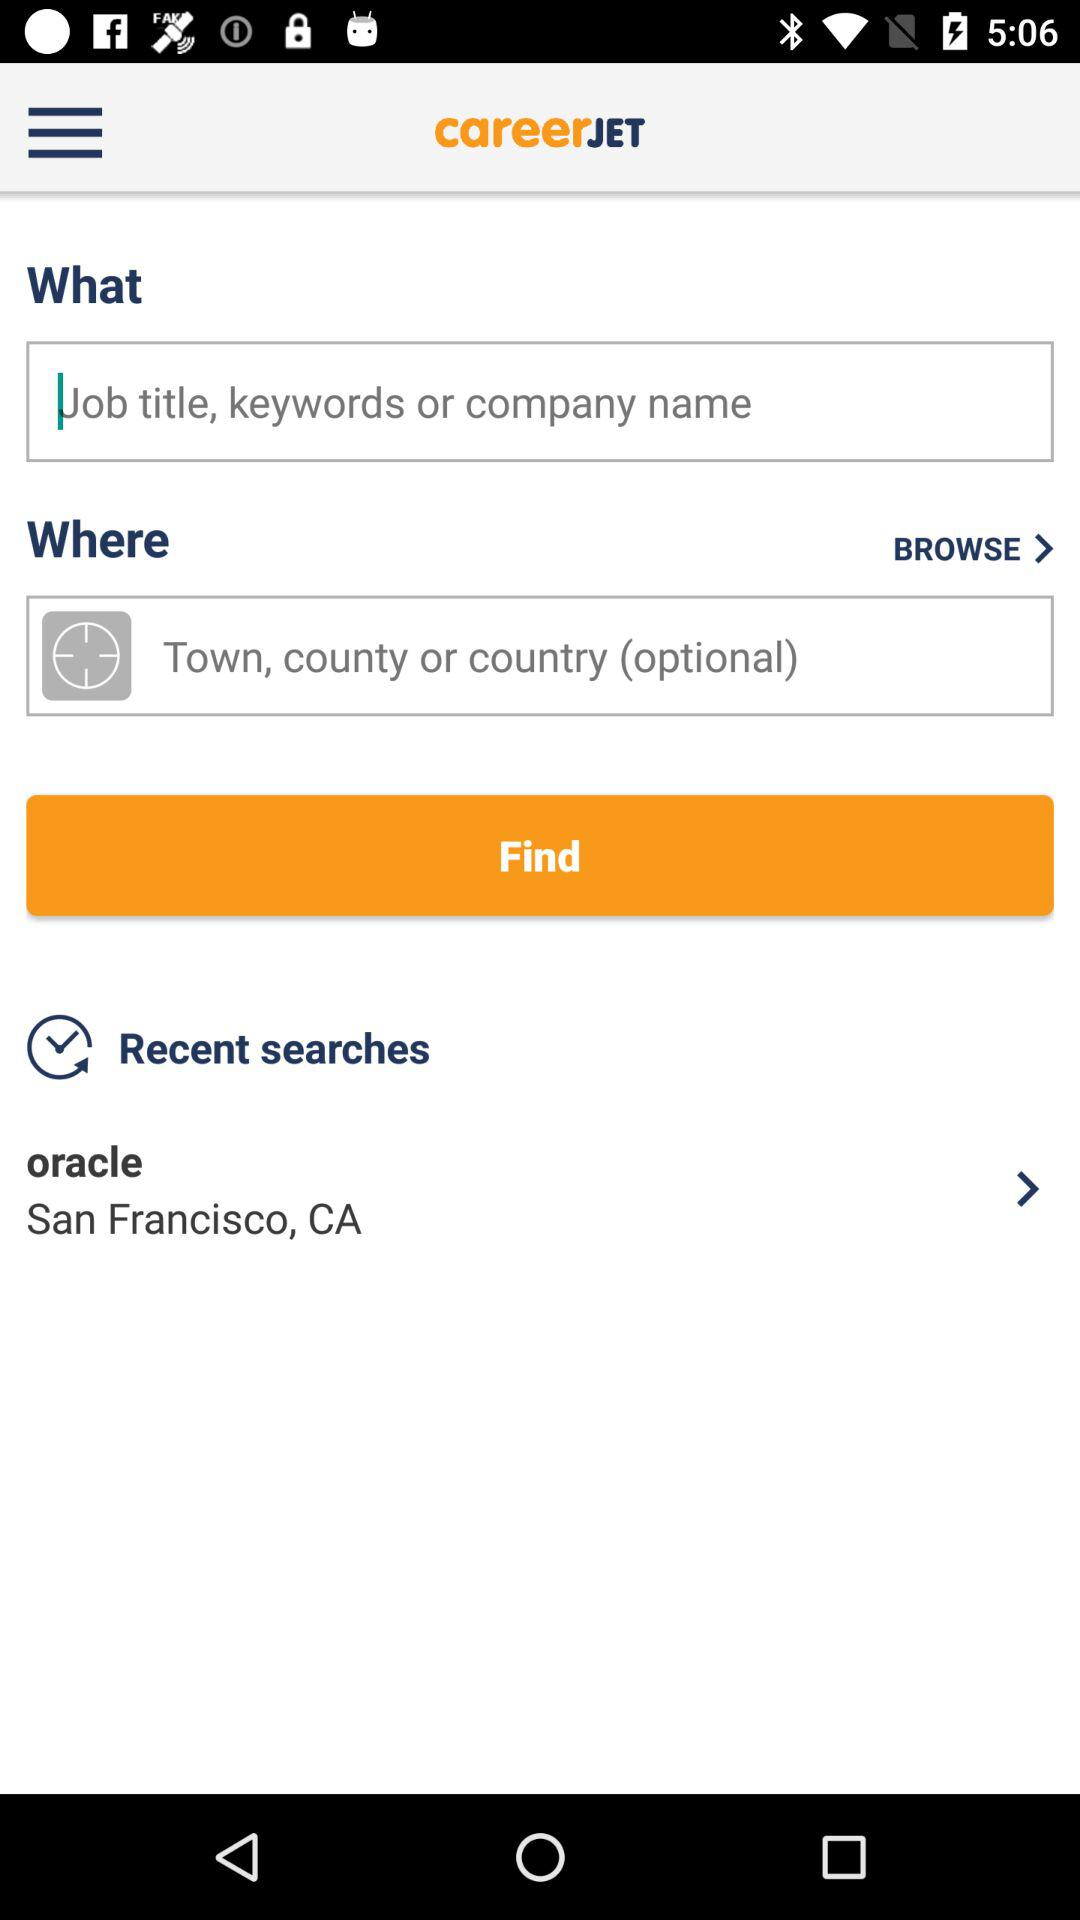What is the mentioned location? The mentioned location is San Francisco, CA. 